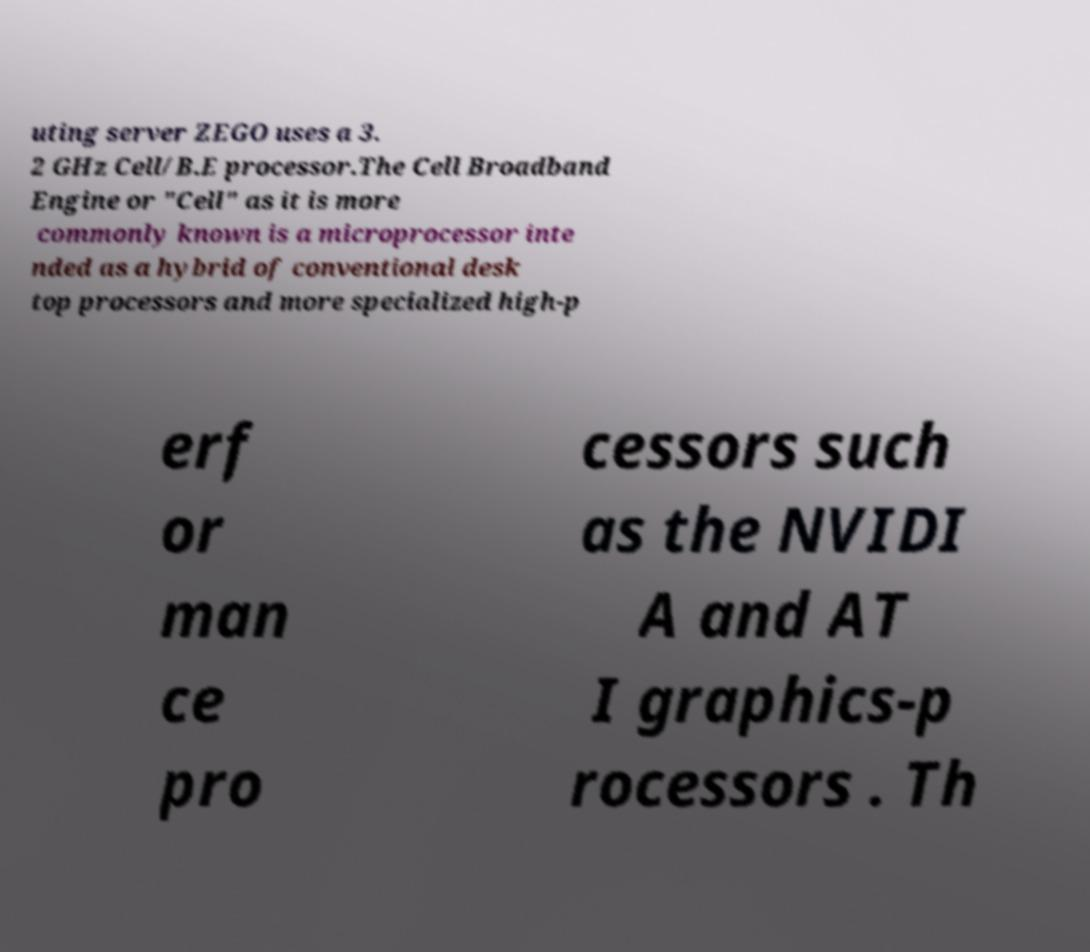I need the written content from this picture converted into text. Can you do that? uting server ZEGO uses a 3. 2 GHz Cell/B.E processor.The Cell Broadband Engine or "Cell" as it is more commonly known is a microprocessor inte nded as a hybrid of conventional desk top processors and more specialized high-p erf or man ce pro cessors such as the NVIDI A and AT I graphics-p rocessors . Th 